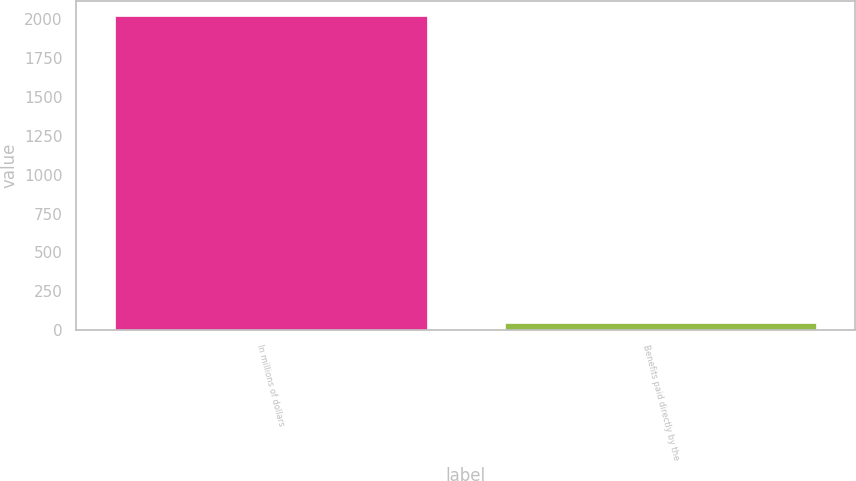<chart> <loc_0><loc_0><loc_500><loc_500><bar_chart><fcel>In millions of dollars<fcel>Benefits paid directly by the<nl><fcel>2017<fcel>45<nl></chart> 